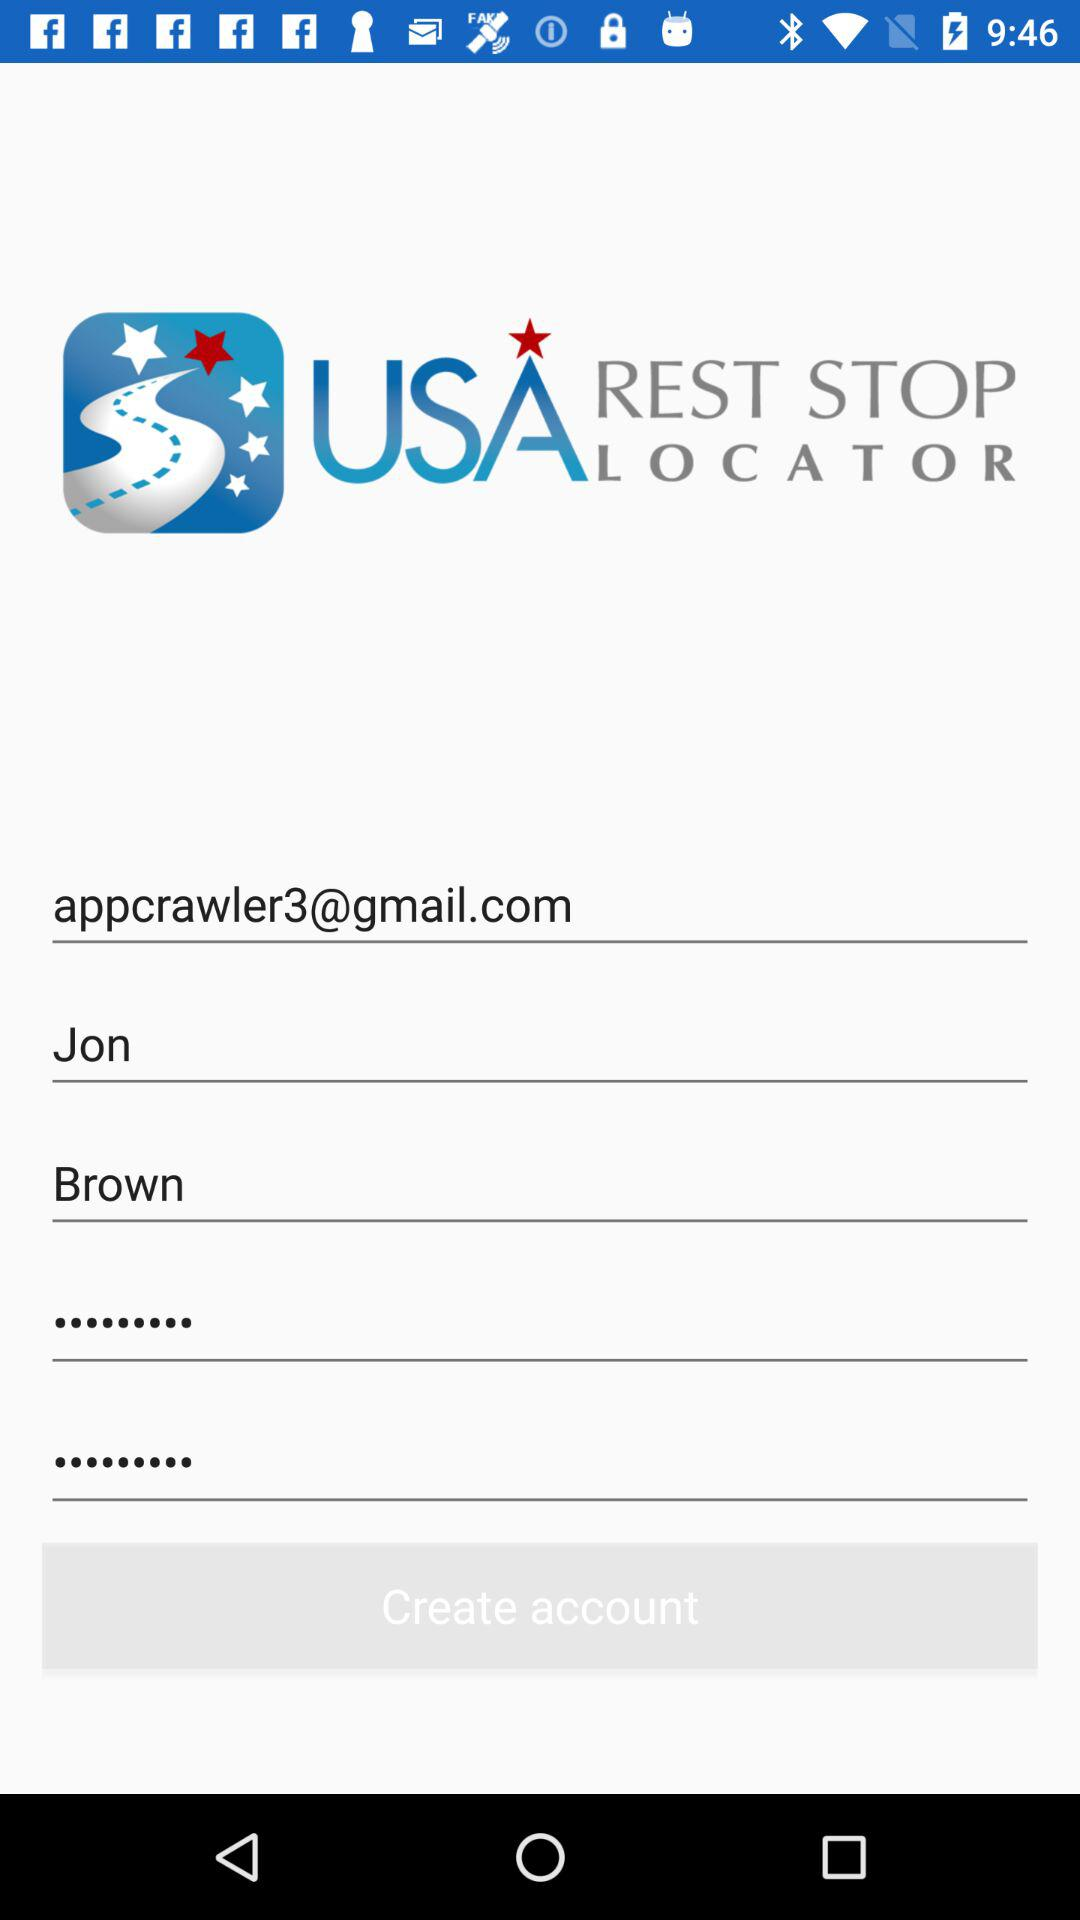What is the entered password?
When the provided information is insufficient, respond with <no answer>. <no answer> 